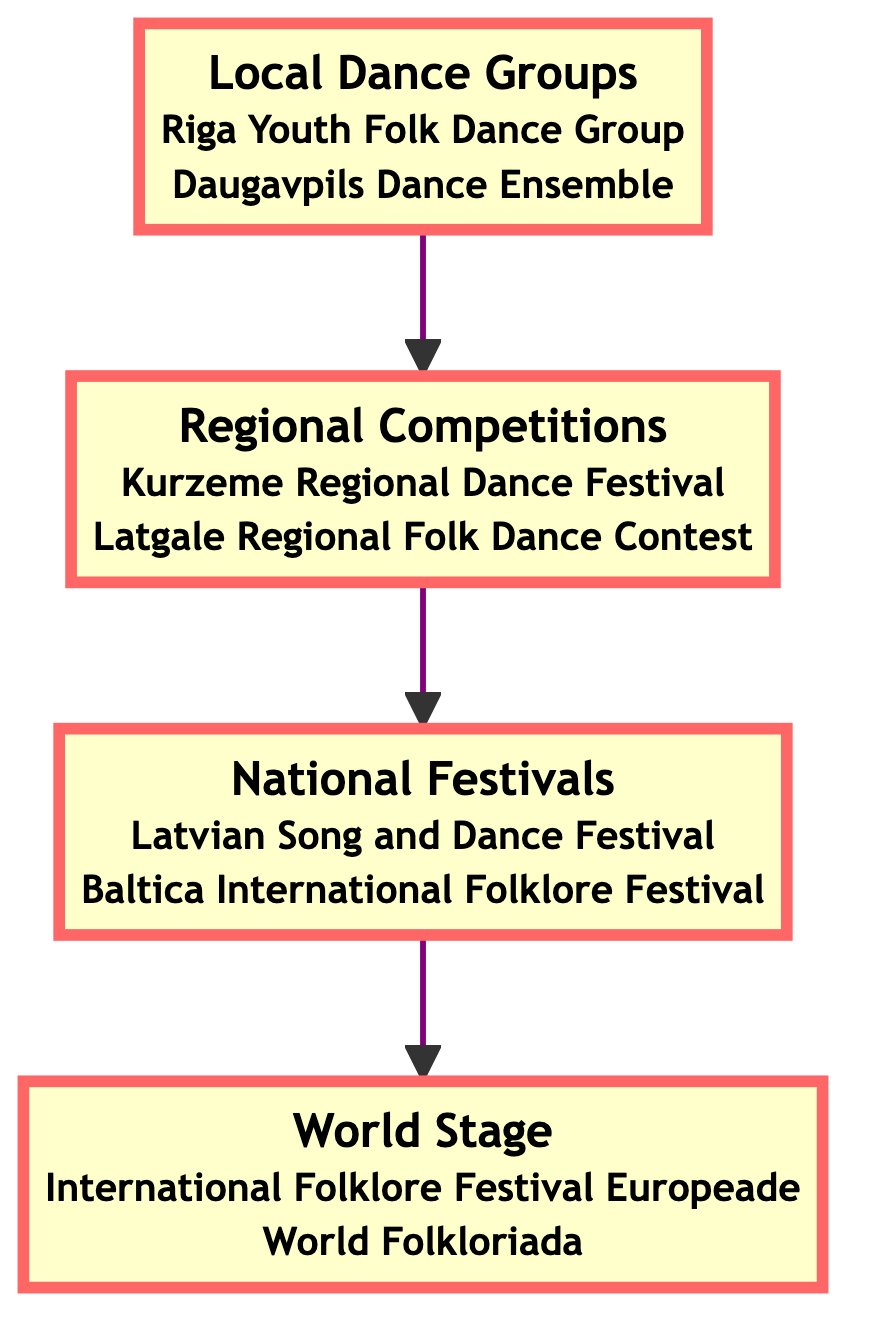What is the highest level in the hierarchy? The highest level in the hierarchy represented by the top node in the flowchart is the World Stage.
Answer: World Stage How many nodes are in the diagram? There are four nodes in the diagram, each representing a level in the hierarchy of folk dance performances.
Answer: 4 What level comes before National Festivals? The level that comes directly before National Festivals in the flowchart is Regional Competitions, as indicated by the arrow pointing upwards.
Answer: Regional Competitions Which example is listed under Local Dance Groups? One of the examples listed under Local Dance Groups is the Riga Youth Folk Dance Group, which is explicitly mentioned in the node description.
Answer: Riga Youth Folk Dance Group What is the relationship between National Festivals and World Stage? The relationship is that National Festivals lead to the World Stage; National Festivals is shown directly below World Stage in the flowchart, indicating a progression.
Answer: Leads to How many examples are provided under Regional Competitions? There are two examples provided under Regional Competitions, as listed in the node description.
Answer: 2 Which level includes the Latvian Song and Dance Festival? The level that includes the Latvian Song and Dance Festival is National Festivals, where it is explicitly mentioned alongside another example.
Answer: National Festivals What is the main purpose of the World Stage level? The main purpose of the World Stage is to promote cultural exchange and global appreciation of Latvian folk dances, as described in the node.
Answer: Cultural exchange What type of groups perform at the Local Dance Groups level? At the Local Dance Groups level, local dancers and amateur groups perform traditional Latvian folk dances, indicating the participant type in this node.
Answer: Local dancers and amateur groups 